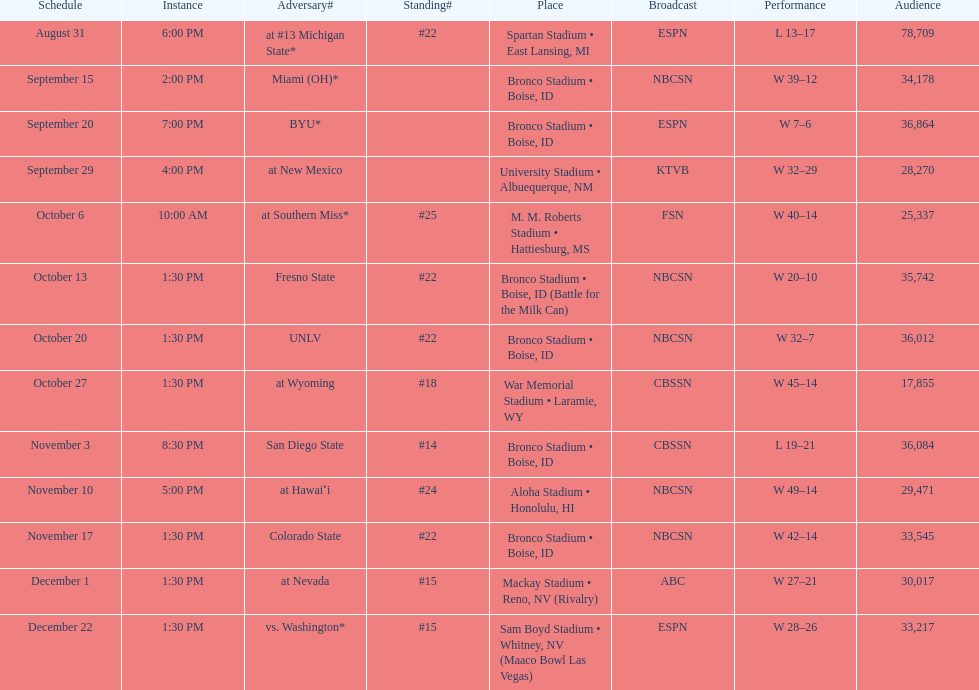In the game against the broncos, what was the total score for miami (oh)? 12. 